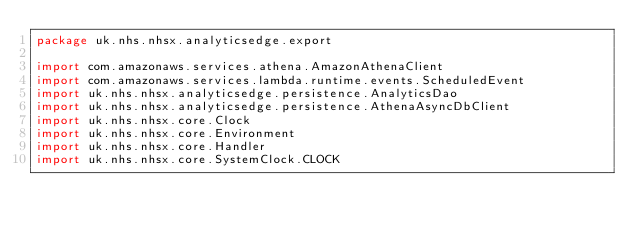<code> <loc_0><loc_0><loc_500><loc_500><_Kotlin_>package uk.nhs.nhsx.analyticsedge.export

import com.amazonaws.services.athena.AmazonAthenaClient
import com.amazonaws.services.lambda.runtime.events.ScheduledEvent
import uk.nhs.nhsx.analyticsedge.persistence.AnalyticsDao
import uk.nhs.nhsx.analyticsedge.persistence.AthenaAsyncDbClient
import uk.nhs.nhsx.core.Clock
import uk.nhs.nhsx.core.Environment
import uk.nhs.nhsx.core.Handler
import uk.nhs.nhsx.core.SystemClock.CLOCK</code> 